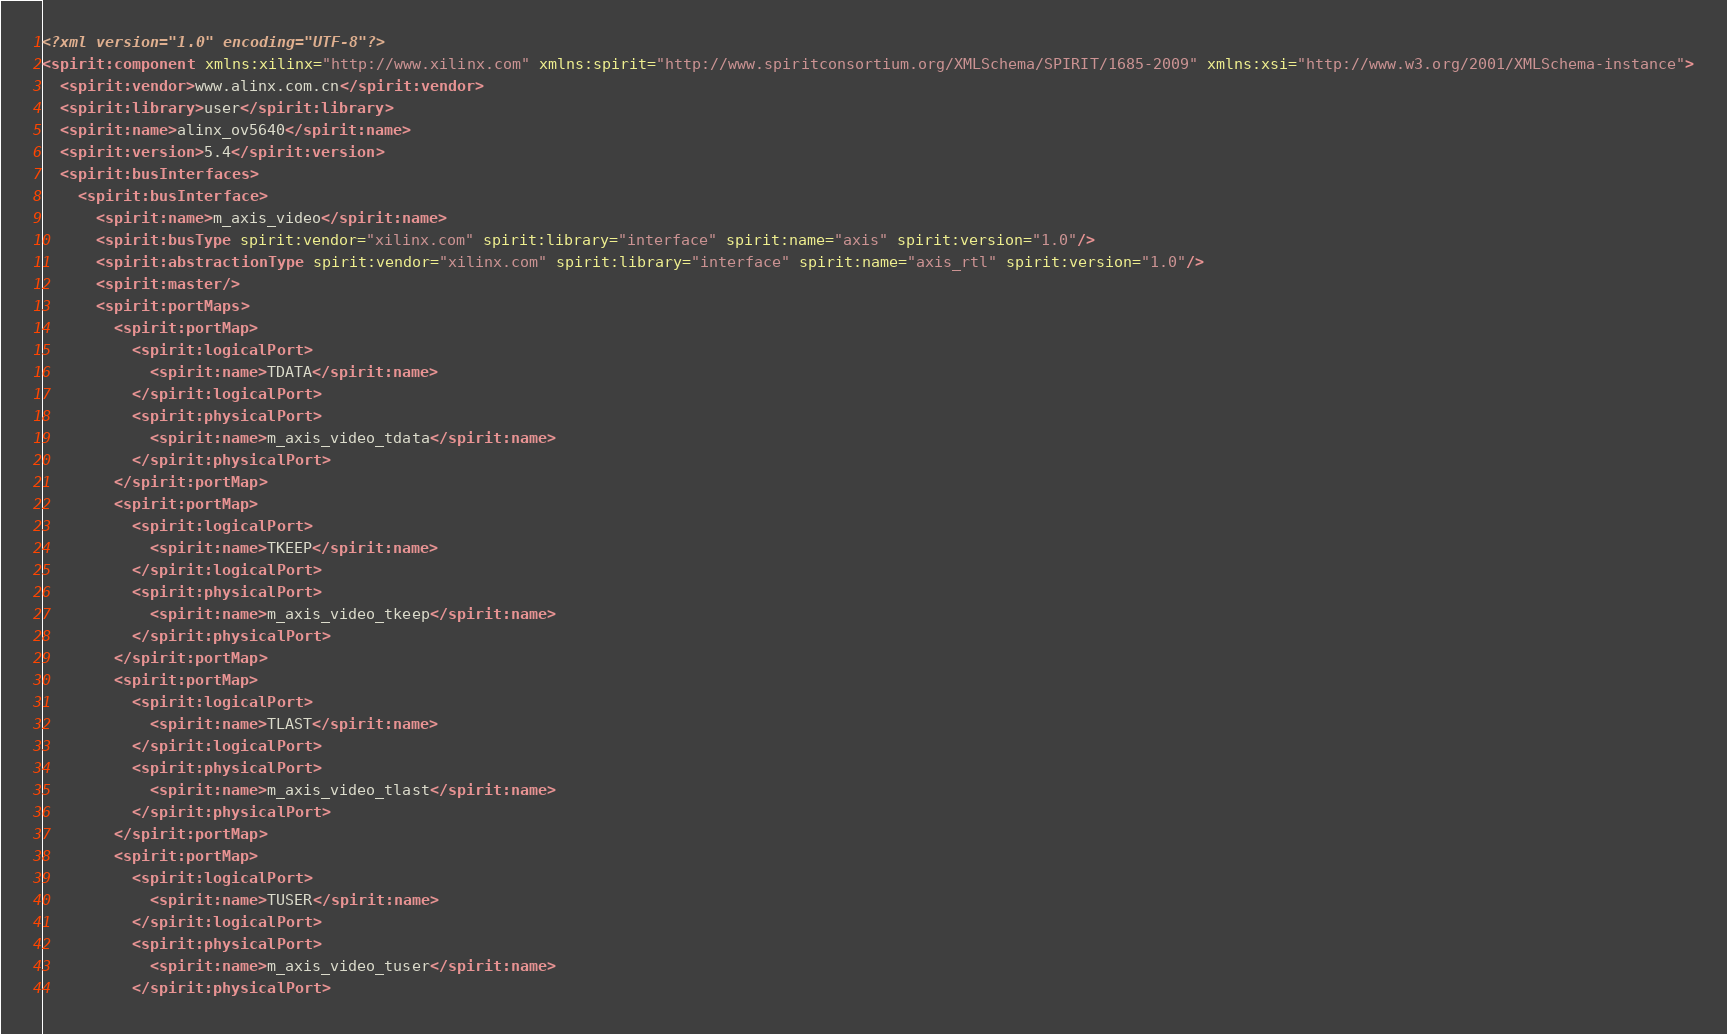Convert code to text. <code><loc_0><loc_0><loc_500><loc_500><_XML_><?xml version="1.0" encoding="UTF-8"?>
<spirit:component xmlns:xilinx="http://www.xilinx.com" xmlns:spirit="http://www.spiritconsortium.org/XMLSchema/SPIRIT/1685-2009" xmlns:xsi="http://www.w3.org/2001/XMLSchema-instance">
  <spirit:vendor>www.alinx.com.cn</spirit:vendor>
  <spirit:library>user</spirit:library>
  <spirit:name>alinx_ov5640</spirit:name>
  <spirit:version>5.4</spirit:version>
  <spirit:busInterfaces>
    <spirit:busInterface>
      <spirit:name>m_axis_video</spirit:name>
      <spirit:busType spirit:vendor="xilinx.com" spirit:library="interface" spirit:name="axis" spirit:version="1.0"/>
      <spirit:abstractionType spirit:vendor="xilinx.com" spirit:library="interface" spirit:name="axis_rtl" spirit:version="1.0"/>
      <spirit:master/>
      <spirit:portMaps>
        <spirit:portMap>
          <spirit:logicalPort>
            <spirit:name>TDATA</spirit:name>
          </spirit:logicalPort>
          <spirit:physicalPort>
            <spirit:name>m_axis_video_tdata</spirit:name>
          </spirit:physicalPort>
        </spirit:portMap>
        <spirit:portMap>
          <spirit:logicalPort>
            <spirit:name>TKEEP</spirit:name>
          </spirit:logicalPort>
          <spirit:physicalPort>
            <spirit:name>m_axis_video_tkeep</spirit:name>
          </spirit:physicalPort>
        </spirit:portMap>
        <spirit:portMap>
          <spirit:logicalPort>
            <spirit:name>TLAST</spirit:name>
          </spirit:logicalPort>
          <spirit:physicalPort>
            <spirit:name>m_axis_video_tlast</spirit:name>
          </spirit:physicalPort>
        </spirit:portMap>
        <spirit:portMap>
          <spirit:logicalPort>
            <spirit:name>TUSER</spirit:name>
          </spirit:logicalPort>
          <spirit:physicalPort>
            <spirit:name>m_axis_video_tuser</spirit:name>
          </spirit:physicalPort></code> 